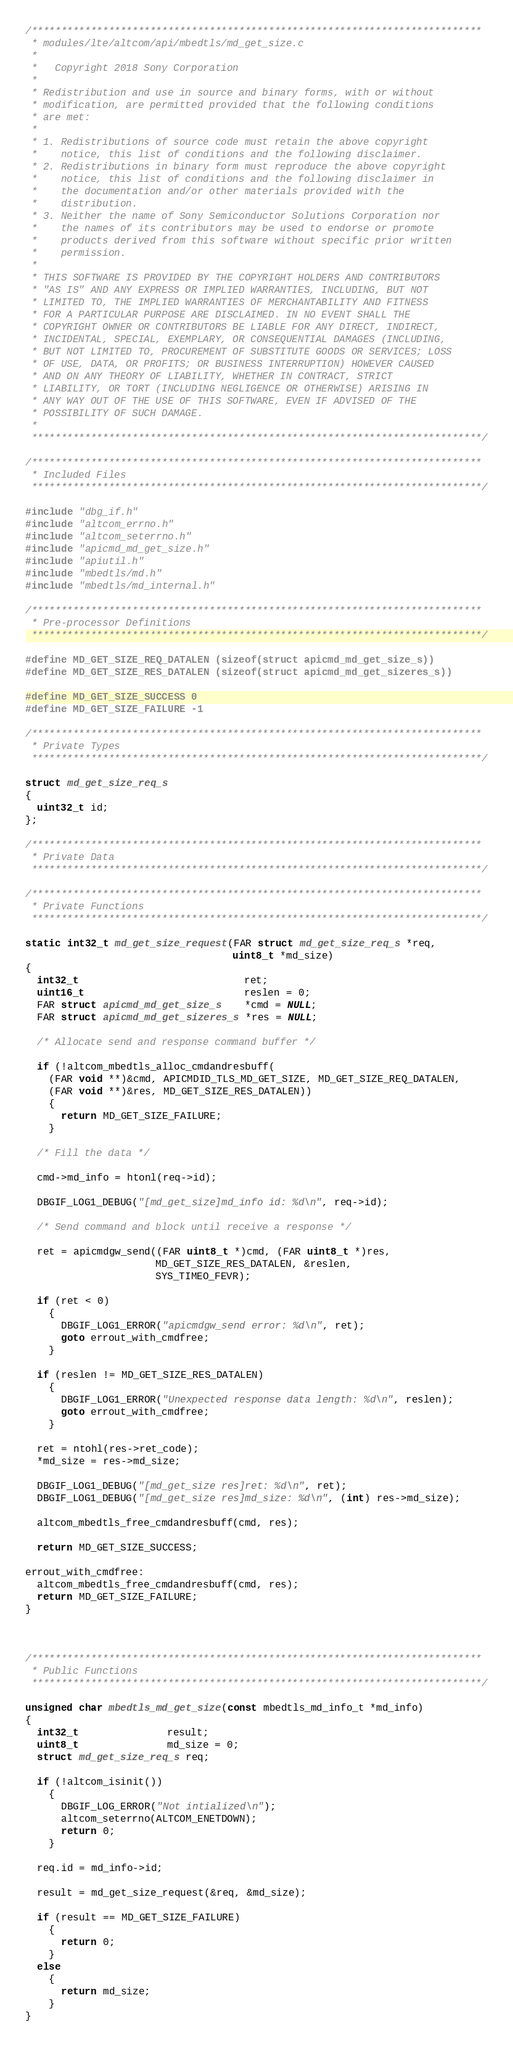<code> <loc_0><loc_0><loc_500><loc_500><_C_>/****************************************************************************
 * modules/lte/altcom/api/mbedtls/md_get_size.c
 *
 *   Copyright 2018 Sony Corporation
 *
 * Redistribution and use in source and binary forms, with or without
 * modification, are permitted provided that the following conditions
 * are met:
 *
 * 1. Redistributions of source code must retain the above copyright
 *    notice, this list of conditions and the following disclaimer.
 * 2. Redistributions in binary form must reproduce the above copyright
 *    notice, this list of conditions and the following disclaimer in
 *    the documentation and/or other materials provided with the
 *    distribution.
 * 3. Neither the name of Sony Semiconductor Solutions Corporation nor
 *    the names of its contributors may be used to endorse or promote
 *    products derived from this software without specific prior written
 *    permission.
 *
 * THIS SOFTWARE IS PROVIDED BY THE COPYRIGHT HOLDERS AND CONTRIBUTORS
 * "AS IS" AND ANY EXPRESS OR IMPLIED WARRANTIES, INCLUDING, BUT NOT
 * LIMITED TO, THE IMPLIED WARRANTIES OF MERCHANTABILITY AND FITNESS
 * FOR A PARTICULAR PURPOSE ARE DISCLAIMED. IN NO EVENT SHALL THE
 * COPYRIGHT OWNER OR CONTRIBUTORS BE LIABLE FOR ANY DIRECT, INDIRECT,
 * INCIDENTAL, SPECIAL, EXEMPLARY, OR CONSEQUENTIAL DAMAGES (INCLUDING,
 * BUT NOT LIMITED TO, PROCUREMENT OF SUBSTITUTE GOODS OR SERVICES; LOSS
 * OF USE, DATA, OR PROFITS; OR BUSINESS INTERRUPTION) HOWEVER CAUSED
 * AND ON ANY THEORY OF LIABILITY, WHETHER IN CONTRACT, STRICT
 * LIABILITY, OR TORT (INCLUDING NEGLIGENCE OR OTHERWISE) ARISING IN
 * ANY WAY OUT OF THE USE OF THIS SOFTWARE, EVEN IF ADVISED OF THE
 * POSSIBILITY OF SUCH DAMAGE.
 *
 ****************************************************************************/

/****************************************************************************
 * Included Files
 ****************************************************************************/

#include "dbg_if.h"
#include "altcom_errno.h"
#include "altcom_seterrno.h"
#include "apicmd_md_get_size.h"
#include "apiutil.h"
#include "mbedtls/md.h"
#include "mbedtls/md_internal.h"

/****************************************************************************
 * Pre-processor Definitions
 ****************************************************************************/

#define MD_GET_SIZE_REQ_DATALEN (sizeof(struct apicmd_md_get_size_s))
#define MD_GET_SIZE_RES_DATALEN (sizeof(struct apicmd_md_get_sizeres_s))

#define MD_GET_SIZE_SUCCESS 0
#define MD_GET_SIZE_FAILURE -1

/****************************************************************************
 * Private Types
 ****************************************************************************/

struct md_get_size_req_s
{
  uint32_t id;
};

/****************************************************************************
 * Private Data
 ****************************************************************************/

/****************************************************************************
 * Private Functions
 ****************************************************************************/

static int32_t md_get_size_request(FAR struct md_get_size_req_s *req,
                                   uint8_t *md_size)
{
  int32_t                            ret;
  uint16_t                           reslen = 0;
  FAR struct apicmd_md_get_size_s    *cmd = NULL;
  FAR struct apicmd_md_get_sizeres_s *res = NULL;

  /* Allocate send and response command buffer */

  if (!altcom_mbedtls_alloc_cmdandresbuff(
    (FAR void **)&cmd, APICMDID_TLS_MD_GET_SIZE, MD_GET_SIZE_REQ_DATALEN,
    (FAR void **)&res, MD_GET_SIZE_RES_DATALEN))
    {
      return MD_GET_SIZE_FAILURE;
    }

  /* Fill the data */

  cmd->md_info = htonl(req->id);

  DBGIF_LOG1_DEBUG("[md_get_size]md_info id: %d\n", req->id);

  /* Send command and block until receive a response */

  ret = apicmdgw_send((FAR uint8_t *)cmd, (FAR uint8_t *)res,
                      MD_GET_SIZE_RES_DATALEN, &reslen,
                      SYS_TIMEO_FEVR);

  if (ret < 0)
    {
      DBGIF_LOG1_ERROR("apicmdgw_send error: %d\n", ret);
      goto errout_with_cmdfree;
    }

  if (reslen != MD_GET_SIZE_RES_DATALEN)
    {
      DBGIF_LOG1_ERROR("Unexpected response data length: %d\n", reslen);
      goto errout_with_cmdfree;
    }

  ret = ntohl(res->ret_code);
  *md_size = res->md_size;

  DBGIF_LOG1_DEBUG("[md_get_size res]ret: %d\n", ret);
  DBGIF_LOG1_DEBUG("[md_get_size res]md_size: %d\n", (int) res->md_size);

  altcom_mbedtls_free_cmdandresbuff(cmd, res);

  return MD_GET_SIZE_SUCCESS;

errout_with_cmdfree:
  altcom_mbedtls_free_cmdandresbuff(cmd, res);
  return MD_GET_SIZE_FAILURE;
}



/****************************************************************************
 * Public Functions
 ****************************************************************************/

unsigned char mbedtls_md_get_size(const mbedtls_md_info_t *md_info)
{
  int32_t               result;
  uint8_t               md_size = 0;
  struct md_get_size_req_s req;

  if (!altcom_isinit())
    {
      DBGIF_LOG_ERROR("Not intialized\n");
      altcom_seterrno(ALTCOM_ENETDOWN);
      return 0;
    }

  req.id = md_info->id;

  result = md_get_size_request(&req, &md_size);

  if (result == MD_GET_SIZE_FAILURE)
    {
      return 0;
    }
  else
    {
      return md_size;
    }
}

</code> 